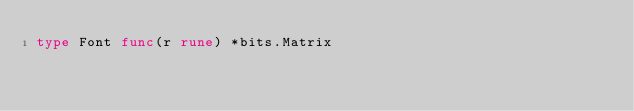Convert code to text. <code><loc_0><loc_0><loc_500><loc_500><_Go_>type Font func(r rune) *bits.Matrix
</code> 